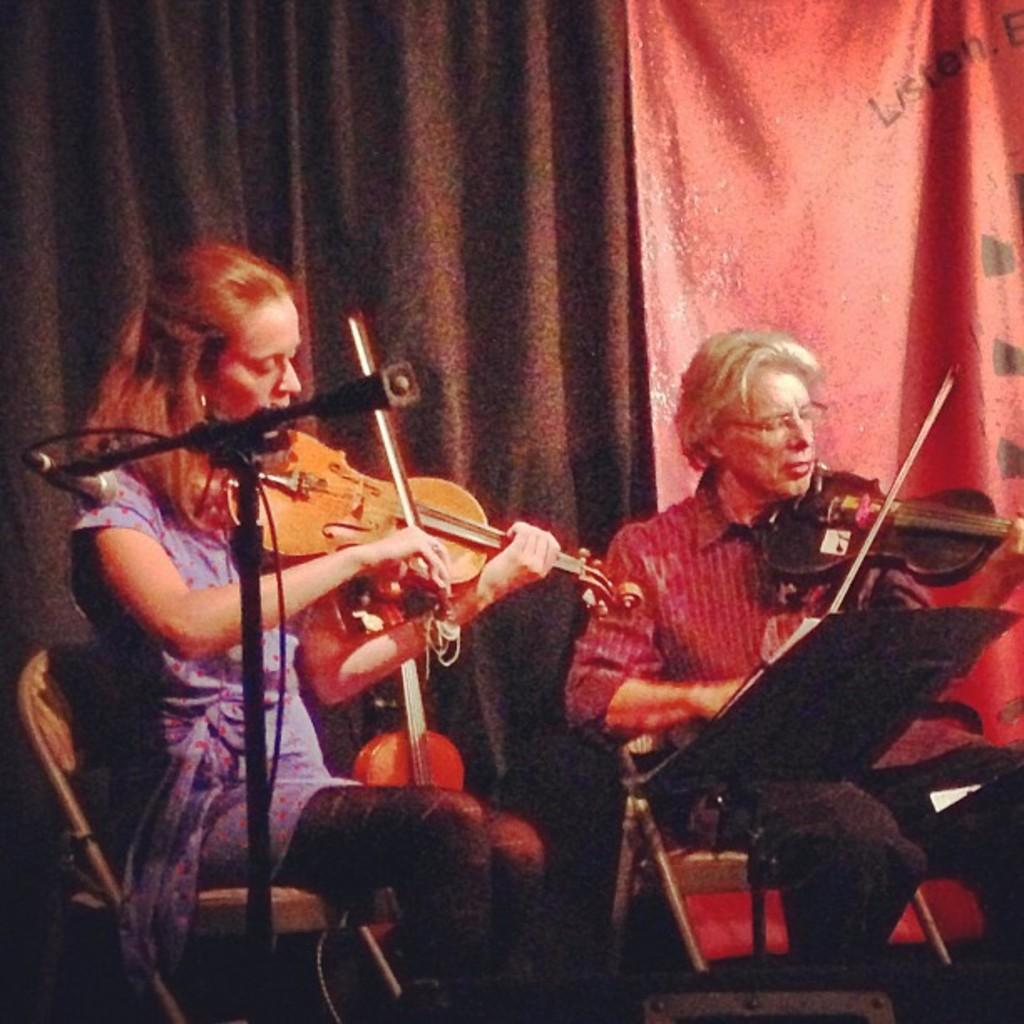In one or two sentences, can you explain what this image depicts? On the background of the picture we can see curtains in brown and red in colour. We can see a man and a women sitting on chairs in front of a mike and playing violin. 